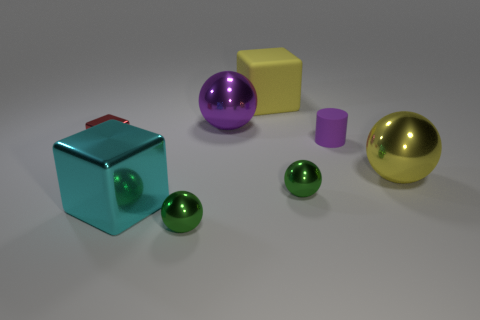Is there anything else that is the same shape as the purple rubber thing?
Offer a very short reply. No. There is a yellow object behind the tiny matte thing; is its size the same as the ball that is behind the tiny purple rubber object?
Provide a succinct answer. Yes. Are there any matte objects of the same shape as the big cyan metal object?
Your answer should be very brief. Yes. Are there an equal number of things that are in front of the big yellow metallic sphere and small metallic objects?
Offer a very short reply. Yes. There is a cyan shiny block; is it the same size as the green sphere right of the purple metal thing?
Offer a very short reply. No. What number of large brown cubes have the same material as the small red thing?
Your response must be concise. 0. Does the purple matte object have the same size as the red cube?
Your answer should be compact. Yes. Is there anything else that has the same color as the tiny cylinder?
Keep it short and to the point. Yes. There is a small thing that is both to the right of the big yellow matte block and in front of the small purple rubber cylinder; what is its shape?
Your response must be concise. Sphere. What is the size of the yellow object that is on the left side of the yellow ball?
Provide a succinct answer. Large. 